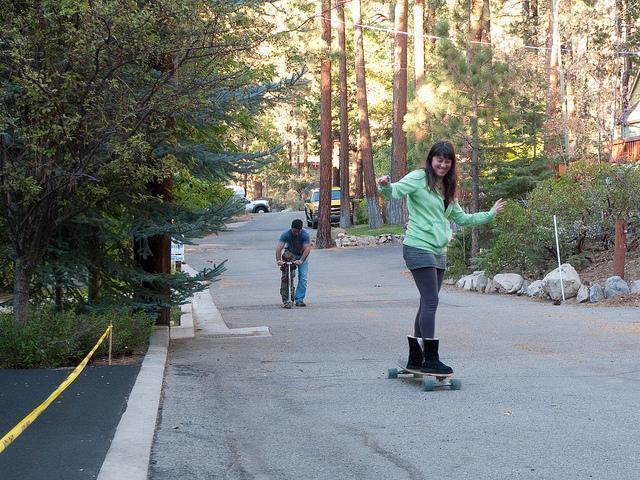What is the Man teaching the child?
Make your selection from the four choices given to correctly answer the question.
Options: Steeple chasing, freebasing, scooter riding, sky diving. Scooter riding. 